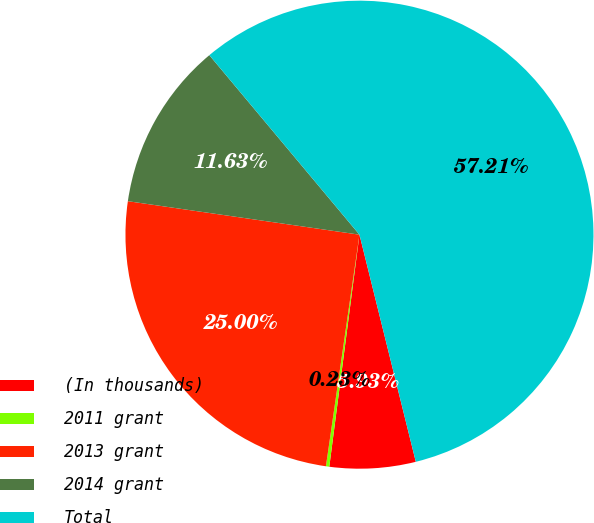Convert chart to OTSL. <chart><loc_0><loc_0><loc_500><loc_500><pie_chart><fcel>(In thousands)<fcel>2011 grant<fcel>2013 grant<fcel>2014 grant<fcel>Total<nl><fcel>5.93%<fcel>0.23%<fcel>25.0%<fcel>11.63%<fcel>57.22%<nl></chart> 